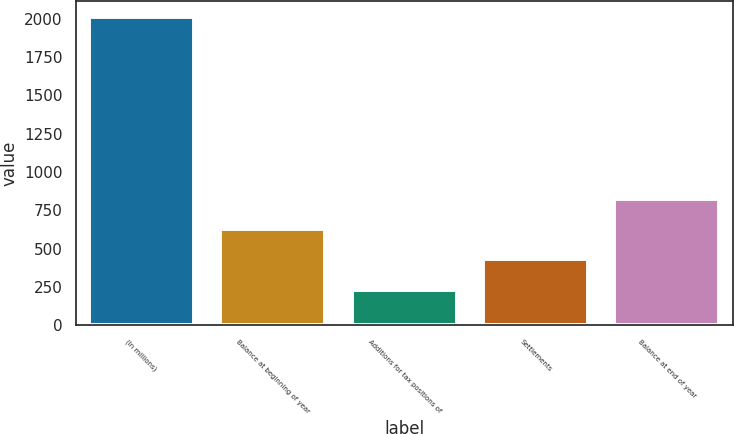Convert chart. <chart><loc_0><loc_0><loc_500><loc_500><bar_chart><fcel>(In millions)<fcel>Balance at beginning of year<fcel>Additions for tax positions of<fcel>Settlements<fcel>Balance at end of year<nl><fcel>2014<fcel>628.91<fcel>233.17<fcel>431.04<fcel>826.78<nl></chart> 